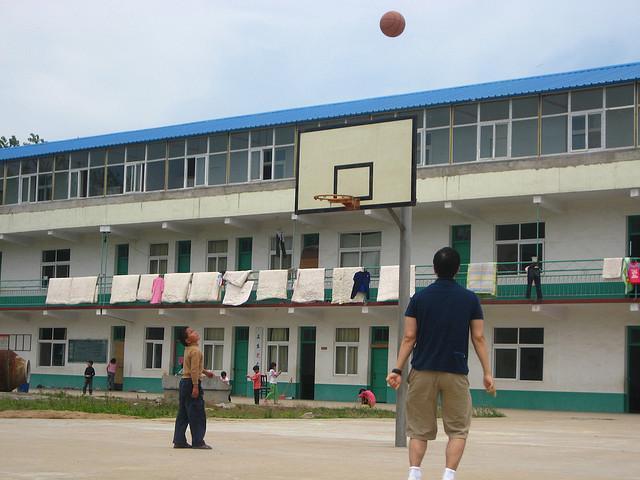How many people can be seen?
Give a very brief answer. 2. 